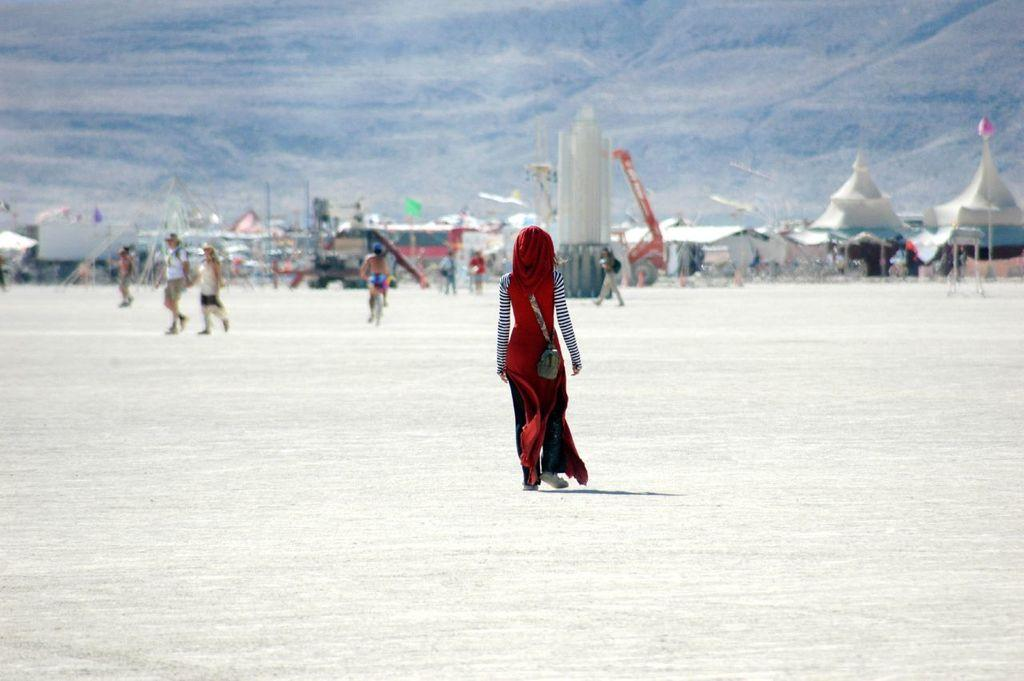What is the main subject of the image? There is a person walking in the image. Where is the person walking? The person is walking on vast land. What can be seen in the background of the image? There are tents in the background of the image. What is visible at the top of the image? The sky is visible at the top of the image. Can you tell me how many dinosaurs are walking alongside the person in the image? There are no dinosaurs present in the image; it features a person walking on vast land with tents in the background. What type of trick is the person performing in the image? There is no trick being performed in the image; the person is simply walking. 